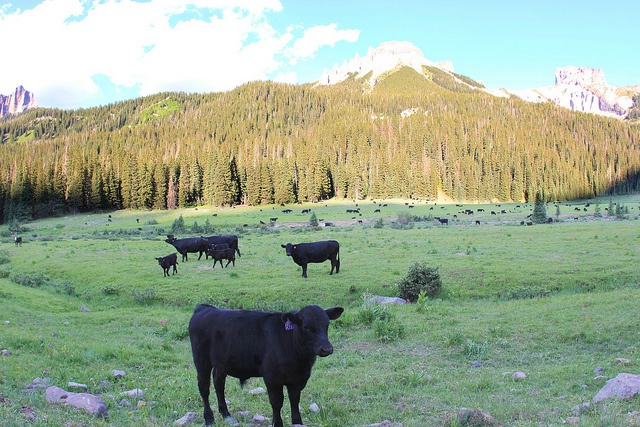Describe the objects in this image and their specific colors. I can see cow in lightblue, black, navy, green, and teal tones, cow in lightblue, black, navy, gray, and darkblue tones, cow in lightblue, black, navy, gray, and darkblue tones, cow in lightblue, black, gray, and darkgray tones, and cow in lightblue, navy, black, darkblue, and gray tones in this image. 